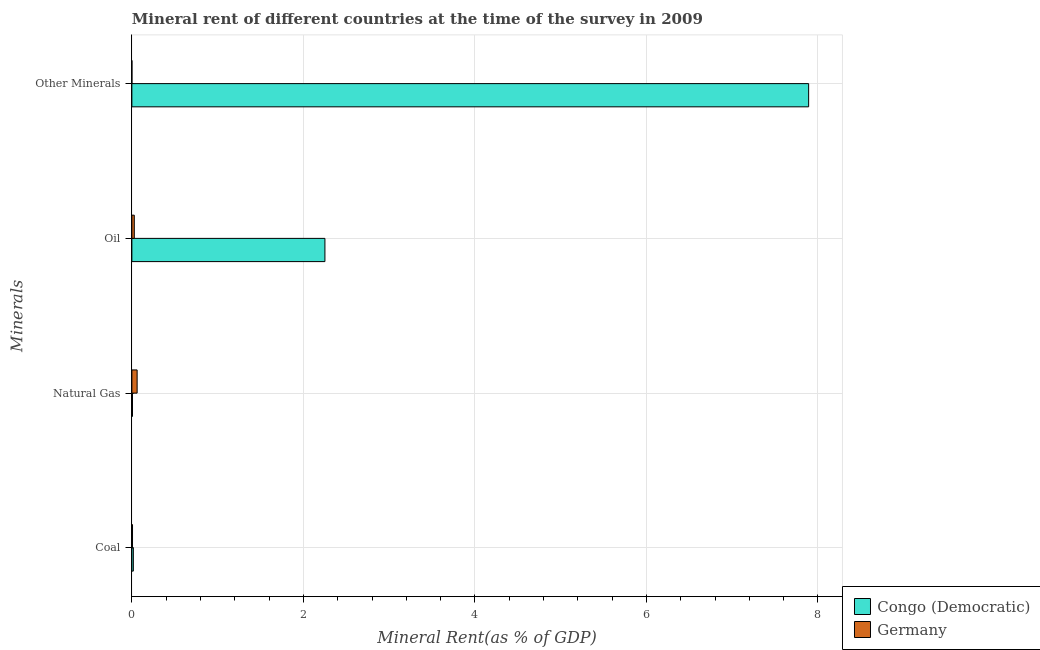Are the number of bars per tick equal to the number of legend labels?
Offer a terse response. Yes. How many bars are there on the 3rd tick from the top?
Offer a terse response. 2. How many bars are there on the 4th tick from the bottom?
Give a very brief answer. 2. What is the label of the 4th group of bars from the top?
Provide a succinct answer. Coal. What is the natural gas rent in Germany?
Provide a succinct answer. 0.06. Across all countries, what is the maximum  rent of other minerals?
Your answer should be very brief. 7.89. Across all countries, what is the minimum coal rent?
Give a very brief answer. 0.01. In which country was the coal rent maximum?
Ensure brevity in your answer.  Congo (Democratic). What is the total  rent of other minerals in the graph?
Give a very brief answer. 7.89. What is the difference between the  rent of other minerals in Germany and that in Congo (Democratic)?
Your response must be concise. -7.89. What is the difference between the natural gas rent in Germany and the coal rent in Congo (Democratic)?
Offer a terse response. 0.04. What is the average oil rent per country?
Your answer should be compact. 1.14. What is the difference between the oil rent and natural gas rent in Congo (Democratic)?
Provide a short and direct response. 2.24. In how many countries, is the coal rent greater than 2.4 %?
Keep it short and to the point. 0. What is the ratio of the natural gas rent in Congo (Democratic) to that in Germany?
Keep it short and to the point. 0.12. Is the difference between the  rent of other minerals in Germany and Congo (Democratic) greater than the difference between the oil rent in Germany and Congo (Democratic)?
Provide a short and direct response. No. What is the difference between the highest and the second highest oil rent?
Offer a very short reply. 2.22. What is the difference between the highest and the lowest  rent of other minerals?
Your response must be concise. 7.89. Is the sum of the oil rent in Congo (Democratic) and Germany greater than the maximum  rent of other minerals across all countries?
Provide a succinct answer. No. What does the 2nd bar from the bottom in Oil represents?
Ensure brevity in your answer.  Germany. How many bars are there?
Make the answer very short. 8. Are all the bars in the graph horizontal?
Ensure brevity in your answer.  Yes. Are the values on the major ticks of X-axis written in scientific E-notation?
Ensure brevity in your answer.  No. Does the graph contain grids?
Offer a very short reply. Yes. How are the legend labels stacked?
Make the answer very short. Vertical. What is the title of the graph?
Keep it short and to the point. Mineral rent of different countries at the time of the survey in 2009. Does "Croatia" appear as one of the legend labels in the graph?
Give a very brief answer. No. What is the label or title of the X-axis?
Provide a succinct answer. Mineral Rent(as % of GDP). What is the label or title of the Y-axis?
Provide a succinct answer. Minerals. What is the Mineral Rent(as % of GDP) of Congo (Democratic) in Coal?
Provide a succinct answer. 0.02. What is the Mineral Rent(as % of GDP) of Germany in Coal?
Provide a succinct answer. 0.01. What is the Mineral Rent(as % of GDP) of Congo (Democratic) in Natural Gas?
Your response must be concise. 0.01. What is the Mineral Rent(as % of GDP) of Germany in Natural Gas?
Ensure brevity in your answer.  0.06. What is the Mineral Rent(as % of GDP) in Congo (Democratic) in Oil?
Provide a short and direct response. 2.25. What is the Mineral Rent(as % of GDP) in Germany in Oil?
Your answer should be very brief. 0.03. What is the Mineral Rent(as % of GDP) in Congo (Democratic) in Other Minerals?
Offer a very short reply. 7.89. What is the Mineral Rent(as % of GDP) in Germany in Other Minerals?
Make the answer very short. 0. Across all Minerals, what is the maximum Mineral Rent(as % of GDP) in Congo (Democratic)?
Offer a terse response. 7.89. Across all Minerals, what is the maximum Mineral Rent(as % of GDP) in Germany?
Provide a succinct answer. 0.06. Across all Minerals, what is the minimum Mineral Rent(as % of GDP) of Congo (Democratic)?
Provide a succinct answer. 0.01. Across all Minerals, what is the minimum Mineral Rent(as % of GDP) in Germany?
Your answer should be compact. 0. What is the total Mineral Rent(as % of GDP) of Congo (Democratic) in the graph?
Provide a short and direct response. 10.17. What is the total Mineral Rent(as % of GDP) of Germany in the graph?
Your response must be concise. 0.1. What is the difference between the Mineral Rent(as % of GDP) in Congo (Democratic) in Coal and that in Natural Gas?
Provide a succinct answer. 0.01. What is the difference between the Mineral Rent(as % of GDP) in Germany in Coal and that in Natural Gas?
Your answer should be compact. -0.05. What is the difference between the Mineral Rent(as % of GDP) of Congo (Democratic) in Coal and that in Oil?
Offer a terse response. -2.23. What is the difference between the Mineral Rent(as % of GDP) in Germany in Coal and that in Oil?
Ensure brevity in your answer.  -0.02. What is the difference between the Mineral Rent(as % of GDP) of Congo (Democratic) in Coal and that in Other Minerals?
Give a very brief answer. -7.87. What is the difference between the Mineral Rent(as % of GDP) in Germany in Coal and that in Other Minerals?
Make the answer very short. 0.01. What is the difference between the Mineral Rent(as % of GDP) in Congo (Democratic) in Natural Gas and that in Oil?
Offer a very short reply. -2.24. What is the difference between the Mineral Rent(as % of GDP) of Germany in Natural Gas and that in Oil?
Your answer should be compact. 0.03. What is the difference between the Mineral Rent(as % of GDP) of Congo (Democratic) in Natural Gas and that in Other Minerals?
Offer a terse response. -7.88. What is the difference between the Mineral Rent(as % of GDP) of Germany in Natural Gas and that in Other Minerals?
Provide a short and direct response. 0.06. What is the difference between the Mineral Rent(as % of GDP) in Congo (Democratic) in Oil and that in Other Minerals?
Your answer should be compact. -5.64. What is the difference between the Mineral Rent(as % of GDP) of Germany in Oil and that in Other Minerals?
Your answer should be compact. 0.03. What is the difference between the Mineral Rent(as % of GDP) of Congo (Democratic) in Coal and the Mineral Rent(as % of GDP) of Germany in Natural Gas?
Make the answer very short. -0.04. What is the difference between the Mineral Rent(as % of GDP) of Congo (Democratic) in Coal and the Mineral Rent(as % of GDP) of Germany in Oil?
Ensure brevity in your answer.  -0.01. What is the difference between the Mineral Rent(as % of GDP) of Congo (Democratic) in Coal and the Mineral Rent(as % of GDP) of Germany in Other Minerals?
Ensure brevity in your answer.  0.02. What is the difference between the Mineral Rent(as % of GDP) in Congo (Democratic) in Natural Gas and the Mineral Rent(as % of GDP) in Germany in Oil?
Ensure brevity in your answer.  -0.02. What is the difference between the Mineral Rent(as % of GDP) of Congo (Democratic) in Natural Gas and the Mineral Rent(as % of GDP) of Germany in Other Minerals?
Offer a very short reply. 0.01. What is the difference between the Mineral Rent(as % of GDP) in Congo (Democratic) in Oil and the Mineral Rent(as % of GDP) in Germany in Other Minerals?
Provide a succinct answer. 2.25. What is the average Mineral Rent(as % of GDP) of Congo (Democratic) per Minerals?
Ensure brevity in your answer.  2.54. What is the average Mineral Rent(as % of GDP) of Germany per Minerals?
Your answer should be very brief. 0.02. What is the difference between the Mineral Rent(as % of GDP) of Congo (Democratic) and Mineral Rent(as % of GDP) of Germany in Coal?
Offer a terse response. 0.01. What is the difference between the Mineral Rent(as % of GDP) in Congo (Democratic) and Mineral Rent(as % of GDP) in Germany in Natural Gas?
Give a very brief answer. -0.05. What is the difference between the Mineral Rent(as % of GDP) of Congo (Democratic) and Mineral Rent(as % of GDP) of Germany in Oil?
Your answer should be very brief. 2.22. What is the difference between the Mineral Rent(as % of GDP) in Congo (Democratic) and Mineral Rent(as % of GDP) in Germany in Other Minerals?
Ensure brevity in your answer.  7.89. What is the ratio of the Mineral Rent(as % of GDP) in Congo (Democratic) in Coal to that in Natural Gas?
Provide a succinct answer. 2.32. What is the ratio of the Mineral Rent(as % of GDP) of Germany in Coal to that in Natural Gas?
Your answer should be compact. 0.12. What is the ratio of the Mineral Rent(as % of GDP) of Congo (Democratic) in Coal to that in Oil?
Offer a terse response. 0.01. What is the ratio of the Mineral Rent(as % of GDP) in Germany in Coal to that in Oil?
Provide a succinct answer. 0.26. What is the ratio of the Mineral Rent(as % of GDP) in Congo (Democratic) in Coal to that in Other Minerals?
Give a very brief answer. 0. What is the ratio of the Mineral Rent(as % of GDP) in Germany in Coal to that in Other Minerals?
Provide a short and direct response. 18.5. What is the ratio of the Mineral Rent(as % of GDP) of Congo (Democratic) in Natural Gas to that in Oil?
Your answer should be very brief. 0. What is the ratio of the Mineral Rent(as % of GDP) of Germany in Natural Gas to that in Oil?
Offer a very short reply. 2.17. What is the ratio of the Mineral Rent(as % of GDP) in Congo (Democratic) in Natural Gas to that in Other Minerals?
Make the answer very short. 0. What is the ratio of the Mineral Rent(as % of GDP) in Germany in Natural Gas to that in Other Minerals?
Offer a terse response. 152.33. What is the ratio of the Mineral Rent(as % of GDP) in Congo (Democratic) in Oil to that in Other Minerals?
Provide a short and direct response. 0.29. What is the ratio of the Mineral Rent(as % of GDP) in Germany in Oil to that in Other Minerals?
Give a very brief answer. 70.15. What is the difference between the highest and the second highest Mineral Rent(as % of GDP) of Congo (Democratic)?
Provide a succinct answer. 5.64. What is the difference between the highest and the second highest Mineral Rent(as % of GDP) in Germany?
Provide a short and direct response. 0.03. What is the difference between the highest and the lowest Mineral Rent(as % of GDP) of Congo (Democratic)?
Offer a terse response. 7.88. What is the difference between the highest and the lowest Mineral Rent(as % of GDP) of Germany?
Your answer should be very brief. 0.06. 